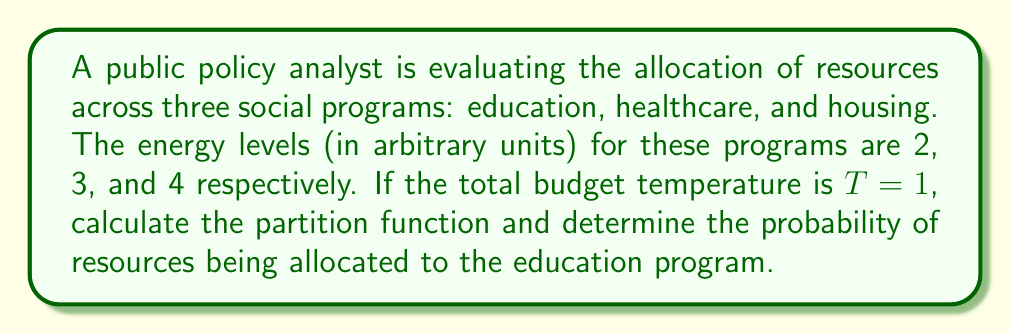Can you answer this question? 1. First, we need to calculate the partition function. The partition function is given by:

   $$Z = \sum_{i} e^{-E_i/T}$$

   where $E_i$ are the energy levels and $T$ is the temperature.

2. Substituting the given values:

   $$Z = e^{-2/1} + e^{-3/1} + e^{-4/1}$$

3. Simplify:

   $$Z = e^{-2} + e^{-3} + e^{-4}$$

4. Calculate the numerical value:

   $$Z \approx 0.1353 + 0.0498 + 0.0183 \approx 0.2034$$

5. To find the probability of resources being allocated to education, we use:

   $$P(\text{education}) = \frac{e^{-E_\text{education}/T}}{Z}$$

6. Substitute the values:

   $$P(\text{education}) = \frac{e^{-2/1}}{0.2034}$$

7. Calculate:

   $$P(\text{education}) \approx \frac{0.1353}{0.2034} \approx 0.6652$$

8. Convert to percentage:

   $$P(\text{education}) \approx 66.52\%$$
Answer: $66.52\%$ 